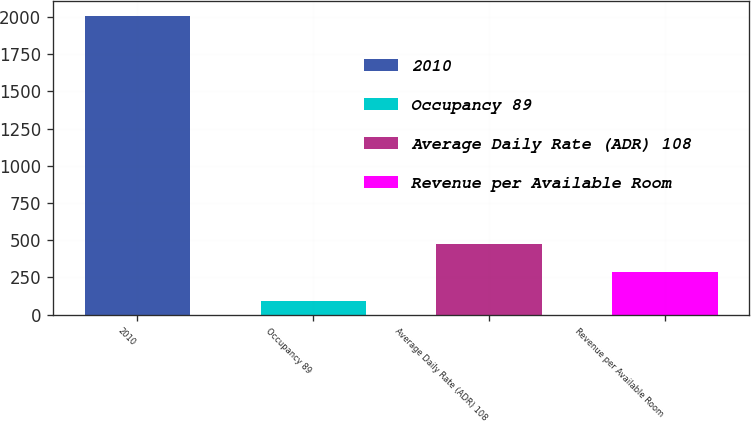Convert chart to OTSL. <chart><loc_0><loc_0><loc_500><loc_500><bar_chart><fcel>2010<fcel>Occupancy 89<fcel>Average Daily Rate (ADR) 108<fcel>Revenue per Available Room<nl><fcel>2008<fcel>92<fcel>475.2<fcel>283.6<nl></chart> 